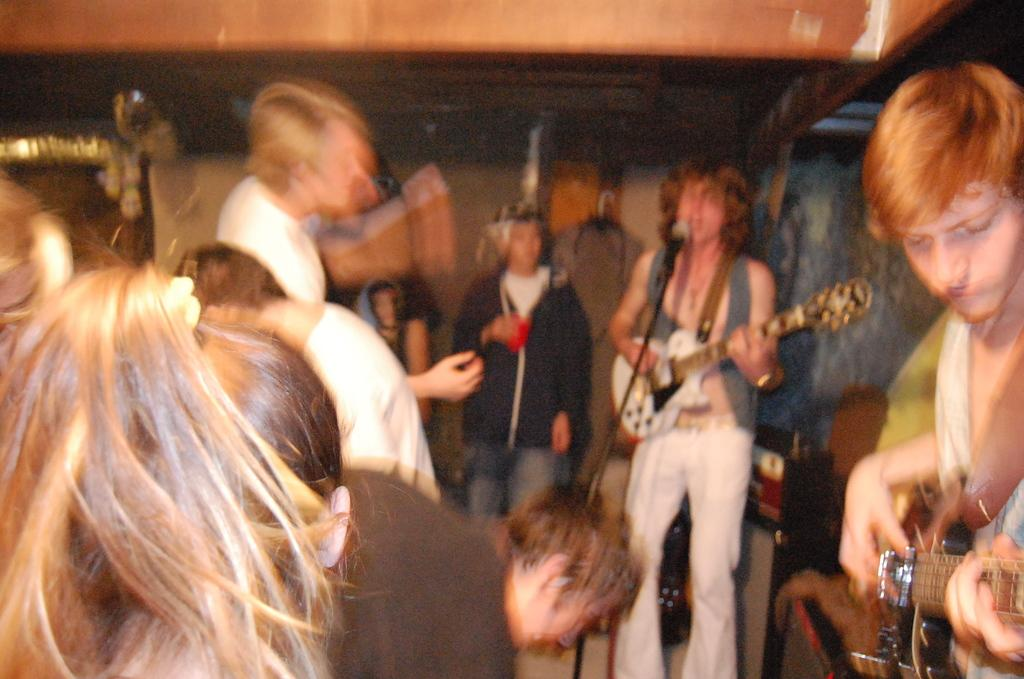How many people are in the image? There are many people in the image. What are the people in the image doing? The people are standing. What are some of the men holding in the image? Some men are holding guitars. What are the other people in the image doing or looking at? The people are looking at the men with guitars. What type of quill is being used by the goldfish in the image? There is no quill or goldfish present in the image. 